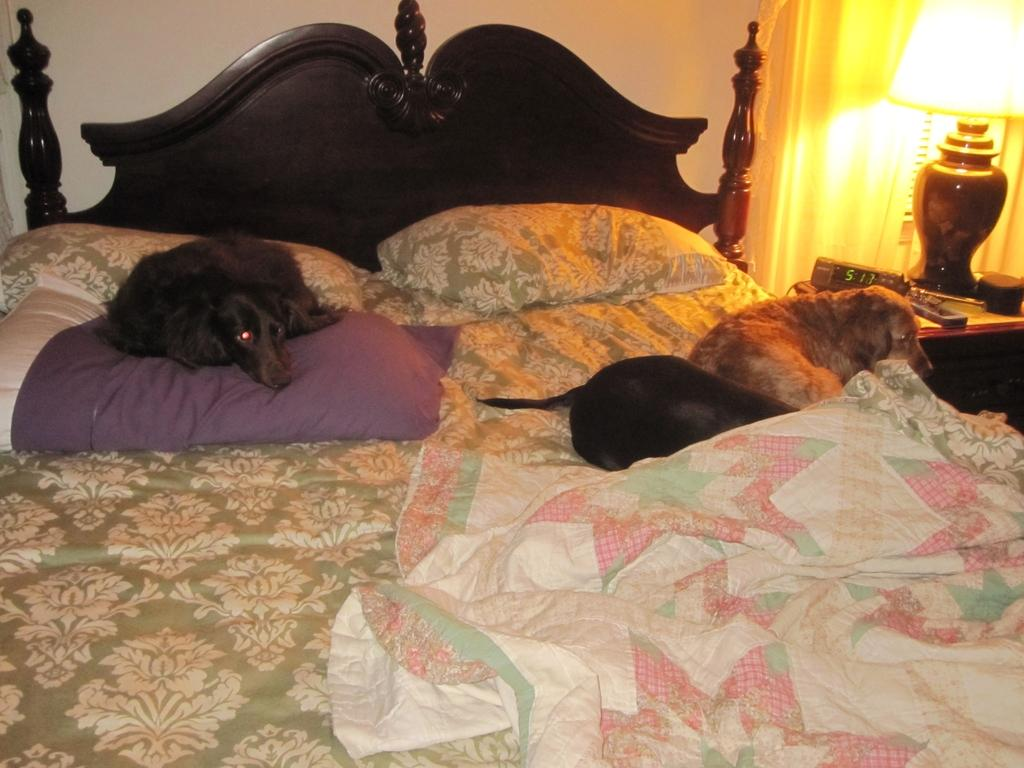What are the dogs doing in the image? The dogs are sleeping on a bed. What is on the bed besides the dogs? The bed has pillows and a bed sheet. What objects can be seen on the table in the image? There is a clock, a lamp, and a remote on the table. What type of window treatment is present in the image? There are curtains in the image. How many points does the goat have in the image? There is no goat present in the image. 